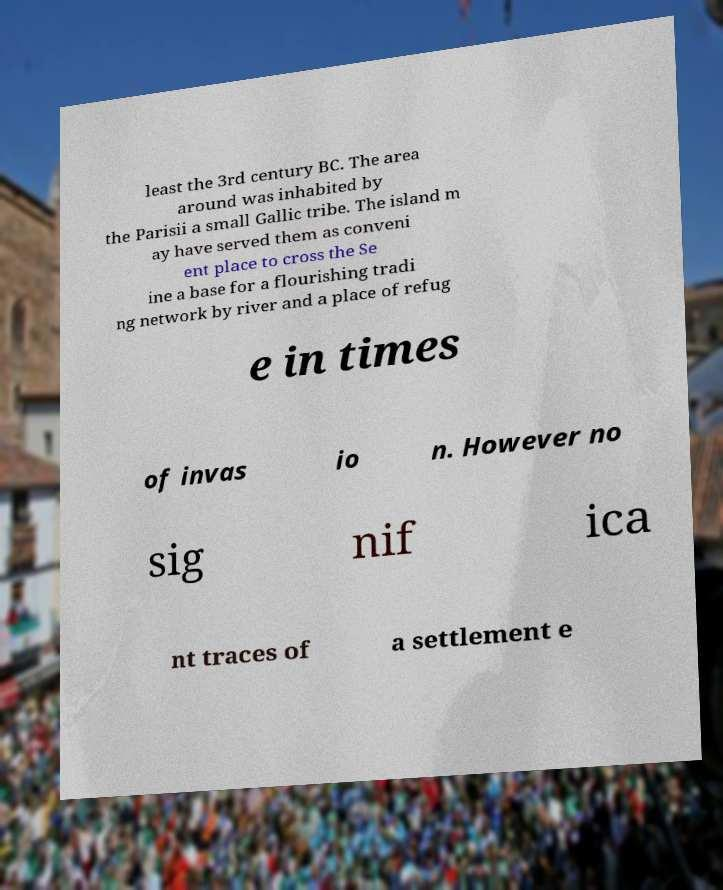Could you assist in decoding the text presented in this image and type it out clearly? least the 3rd century BC. The area around was inhabited by the Parisii a small Gallic tribe. The island m ay have served them as conveni ent place to cross the Se ine a base for a flourishing tradi ng network by river and a place of refug e in times of invas io n. However no sig nif ica nt traces of a settlement e 